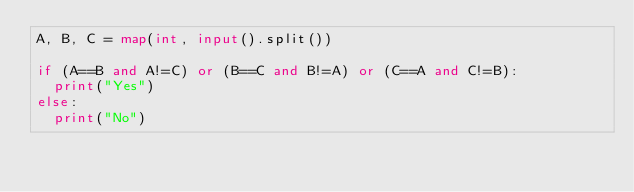<code> <loc_0><loc_0><loc_500><loc_500><_Python_>A, B, C = map(int, input().split())

if (A==B and A!=C) or (B==C and B!=A) or (C==A and C!=B):
  print("Yes")
else:
  print("No")</code> 